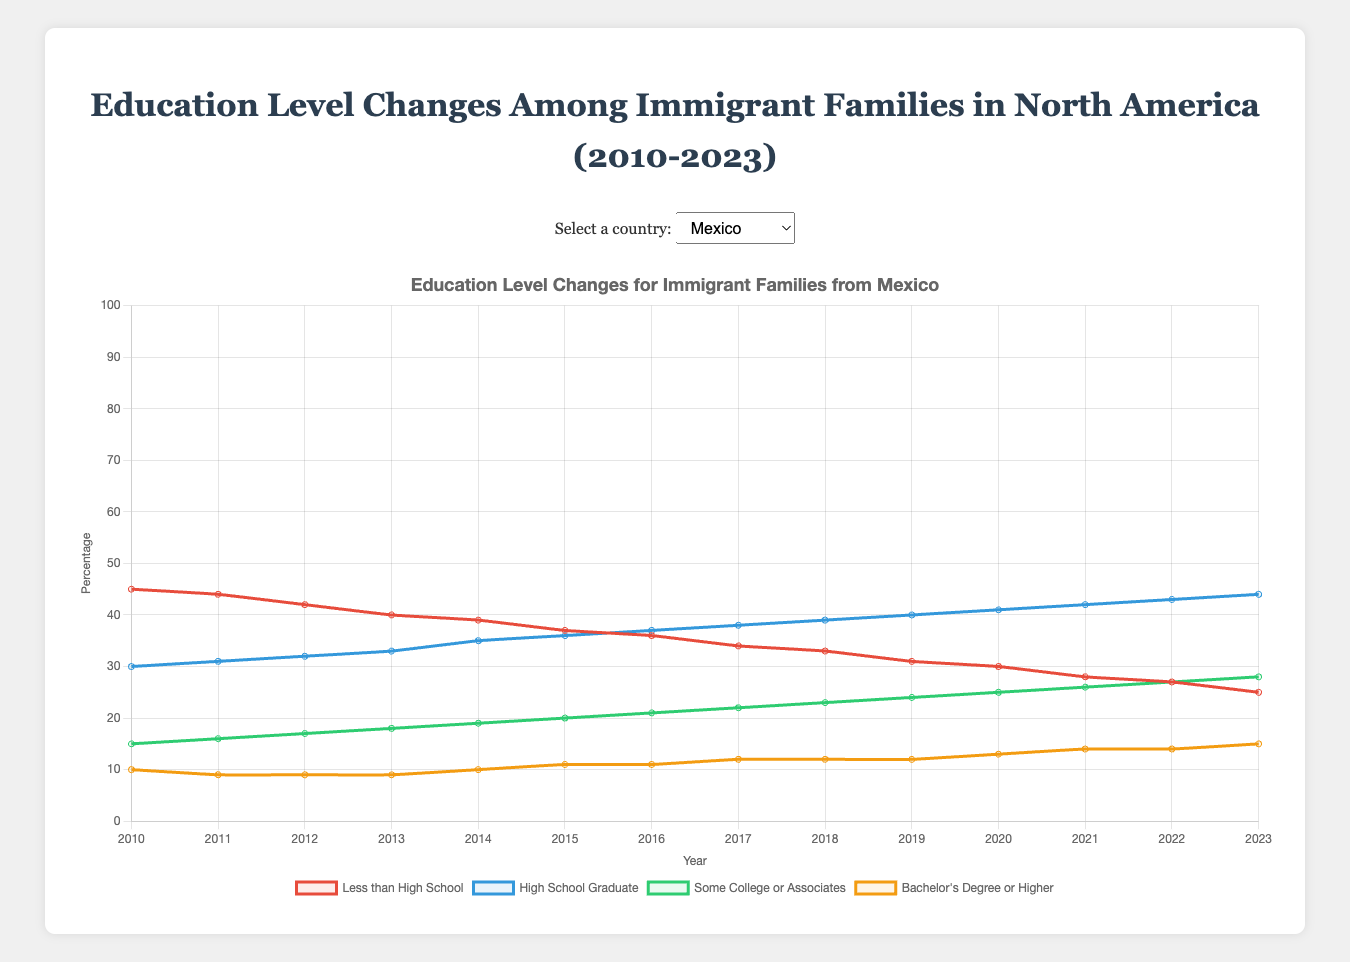What trend do we observe in the percentage of immigrant families from Mexico with less than a high school education from 2010 to 2023? From 2010 to 2023, the percentage of immigrant families from Mexico with less than a high school education steadily decreased from 45% to 25%. This indicates a consistent improvement in education levels within this demographic over the years.
Answer: Decrease from 45% to 25% Which country shows the highest increase in the percentage of immigrant families with a bachelor's degree or higher from 2010 to 2023? To determine this, look at the increase in the "bachelor's degree or higher" category for each country. India shows an increase from 40% to 46%, a 6% increase, whereas China increases from 30% to 45%, a 15% increase. Comparing others, China shows the highest increase.
Answer: China In 2023, which country had the lowest percentage of immigrant families with less than a high school education? In 2023, looking at the "less than high school" percentages, Mexico is at 25%, India is at 3%, China is at 8%, Philippines at 14%, and Haiti at 36%. India has the lowest percentage at 3%.
Answer: India How did the percentage of immigrant families from Haiti with a high school graduate education change from 2010 to 2023? In 2010, the percentage for Haiti was 25% for high school graduates. This increased to 37% by 2023. Therefore, there was an increase of 12 percentage points over the 13-year period.
Answer: Increase from 25% to 37% By how many percentage points did the percentage of Mexican families with some college or associate's degree change from 2010 to 2016? Observing the data for Mexico, the percentage for "some college or associates" was 15% in 2010 and rose to 21% in 2016. Subtracting 15 from 21, we get an increase of 6 percentage points.
Answer: Increase of 6 percentage points Compare the trend in the percentage of families with a high school graduate education in Mexico and the Philippines from 2010 to 2023. In Mexico, the percentage of high school graduates increased from 30% in 2010 to 44% in 2023. In the Philippines, the percentage went from 35% in 2010 to 30% in 2023. Mexico shows an increasing trend, whereas the Philippines shows a slight decreasing trend.
Answer: Mexico increased, Philippines decreased What visual color represents the "bachelor's degree or higher" education level on the chart? The color used for the "bachelor's degree or higher" education level is orange. This is identifiable by the corresponding line and label in the chart's legend.
Answer: Orange What is the combined percentage of immigrant families from China with some college or associate degree and bachelor's degree or higher in 2023? For China in 2023, "some college or associate's" is 27% and "bachelor's degree or higher" is 45%. Adding these together, 27 + 45, we get a combined percentage of 72%.
Answer: 72% Between 2010 and 2023, which country shows the most significant decrease in the percentage of less than high school education? By comparing the decrease in less than high school education percentages between 2010 and 2023 for each country: Mexico decreased by 20% (45% to 25%), India by 7% (10% to 3%), China by 7% (15% to 8%), Philippines by 6% (20% to 14%), and Haiti by 19% (55% to 36%). Mexico shows the most significant decrease.
Answer: Mexico 